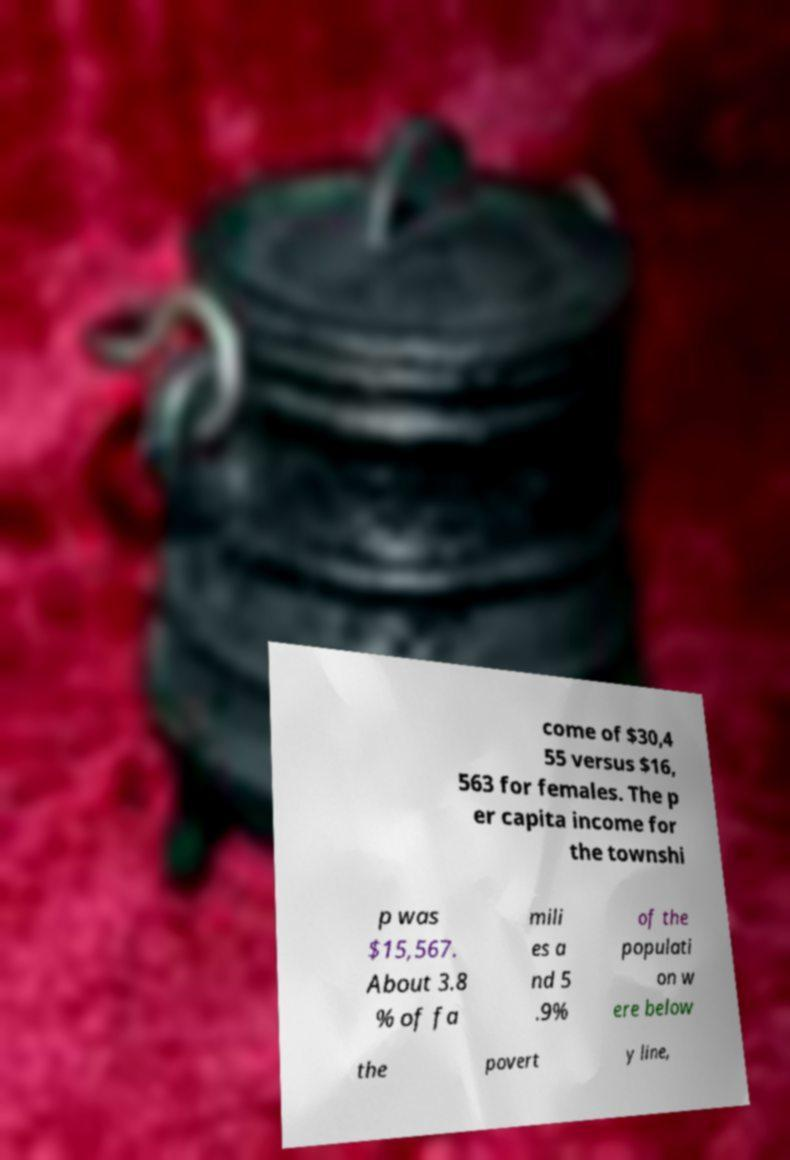What messages or text are displayed in this image? I need them in a readable, typed format. come of $30,4 55 versus $16, 563 for females. The p er capita income for the townshi p was $15,567. About 3.8 % of fa mili es a nd 5 .9% of the populati on w ere below the povert y line, 